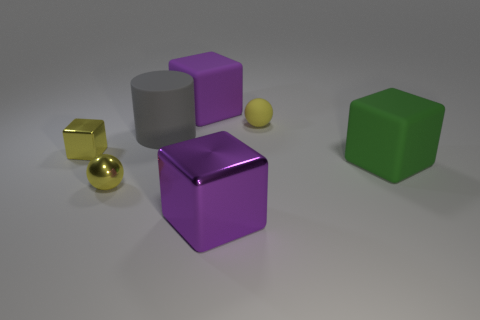Subtract all cyan blocks. Subtract all red cylinders. How many blocks are left? 4 Add 2 big cubes. How many objects exist? 9 Subtract all cylinders. How many objects are left? 6 Subtract all small brown shiny spheres. Subtract all small metal objects. How many objects are left? 5 Add 1 big green cubes. How many big green cubes are left? 2 Add 5 brown rubber objects. How many brown rubber objects exist? 5 Subtract 0 purple cylinders. How many objects are left? 7 